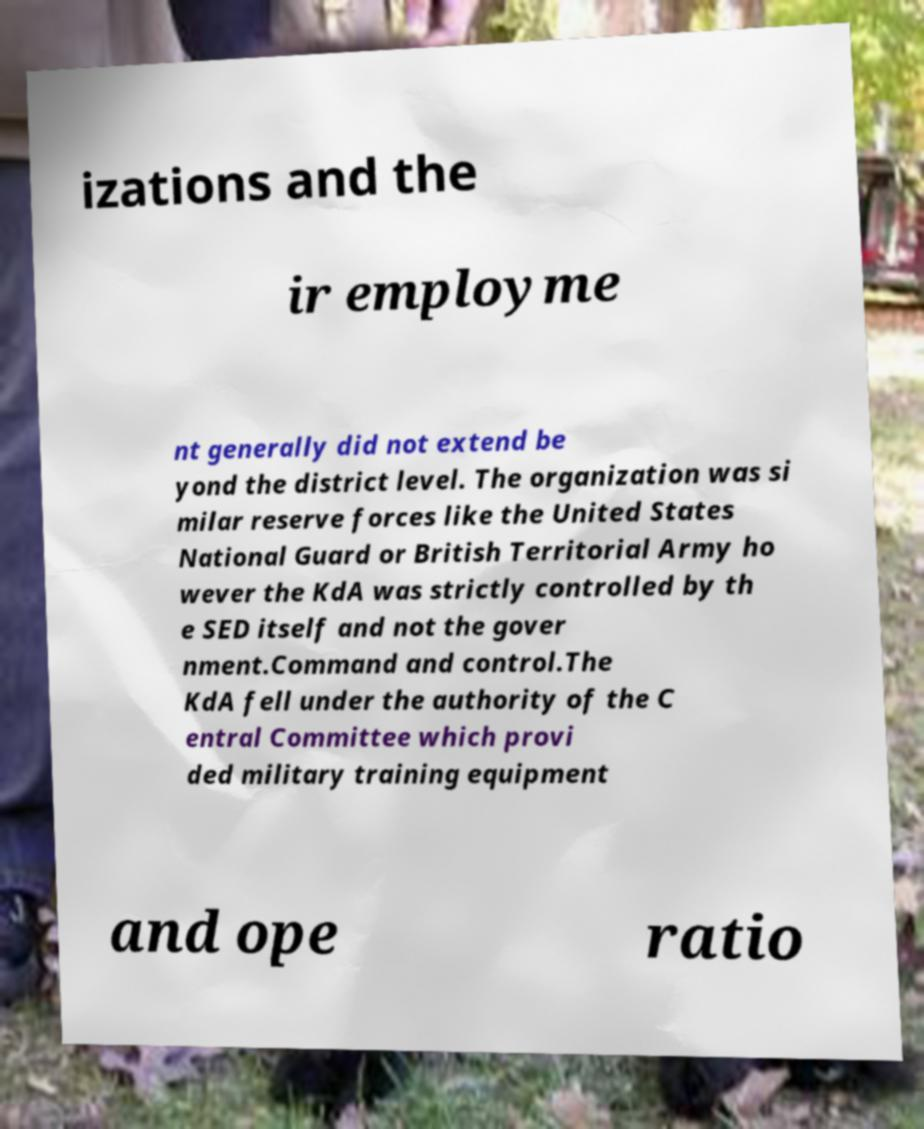Could you extract and type out the text from this image? izations and the ir employme nt generally did not extend be yond the district level. The organization was si milar reserve forces like the United States National Guard or British Territorial Army ho wever the KdA was strictly controlled by th e SED itself and not the gover nment.Command and control.The KdA fell under the authority of the C entral Committee which provi ded military training equipment and ope ratio 